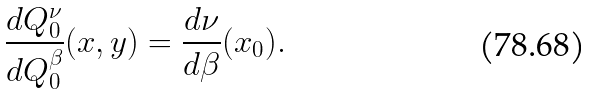<formula> <loc_0><loc_0><loc_500><loc_500>\frac { d Q ^ { \nu } _ { 0 } } { d Q ^ { \beta } _ { 0 } } ( x , y ) = \frac { d \nu } { d \beta } ( x _ { 0 } ) .</formula> 